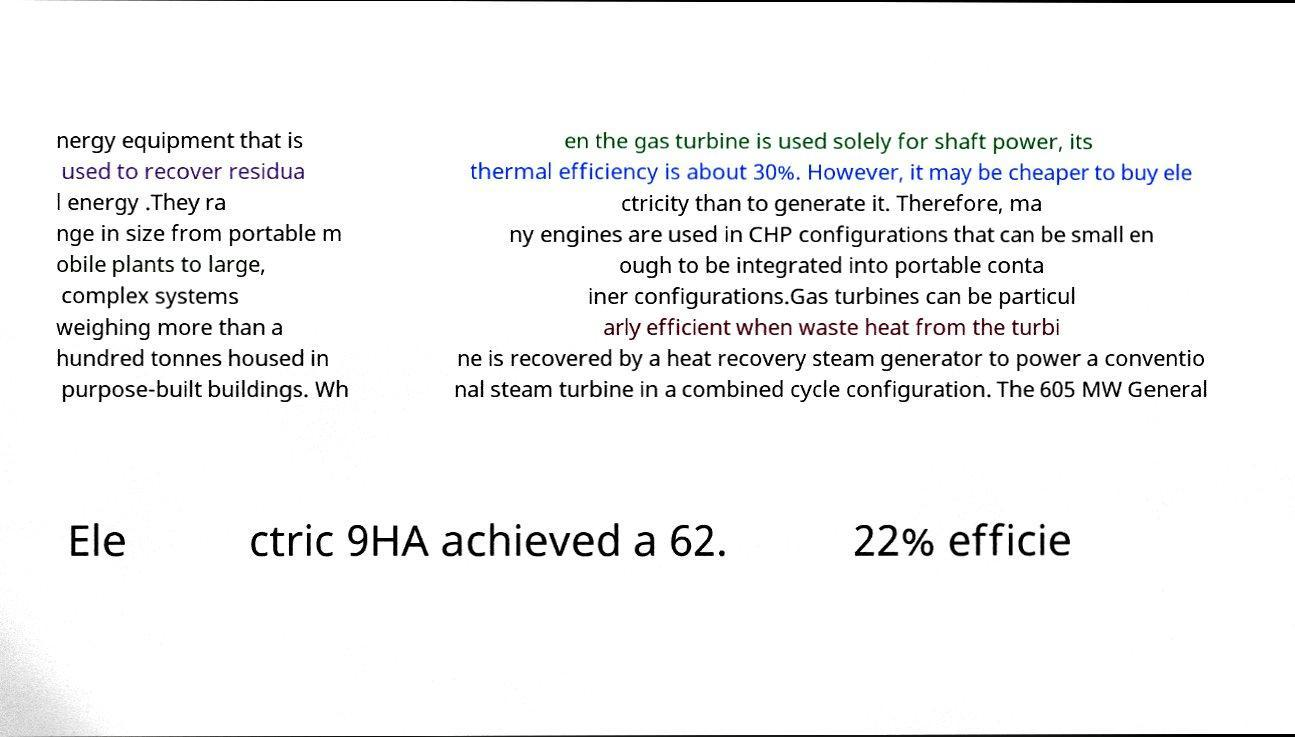Please read and relay the text visible in this image. What does it say? nergy equipment that is used to recover residua l energy .They ra nge in size from portable m obile plants to large, complex systems weighing more than a hundred tonnes housed in purpose-built buildings. Wh en the gas turbine is used solely for shaft power, its thermal efficiency is about 30%. However, it may be cheaper to buy ele ctricity than to generate it. Therefore, ma ny engines are used in CHP configurations that can be small en ough to be integrated into portable conta iner configurations.Gas turbines can be particul arly efficient when waste heat from the turbi ne is recovered by a heat recovery steam generator to power a conventio nal steam turbine in a combined cycle configuration. The 605 MW General Ele ctric 9HA achieved a 62. 22% efficie 